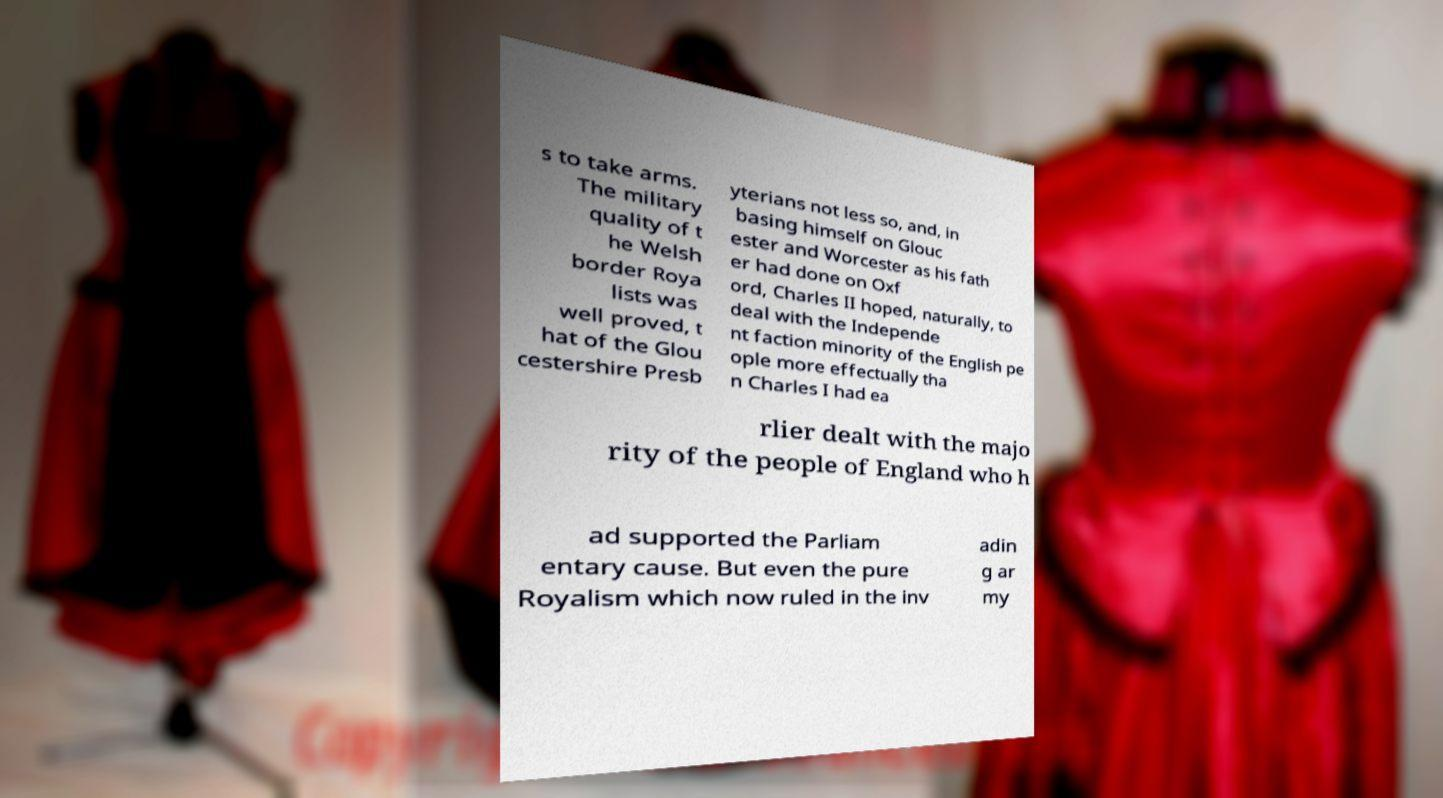Please read and relay the text visible in this image. What does it say? s to take arms. The military quality of t he Welsh border Roya lists was well proved, t hat of the Glou cestershire Presb yterians not less so, and, in basing himself on Glouc ester and Worcester as his fath er had done on Oxf ord, Charles II hoped, naturally, to deal with the Independe nt faction minority of the English pe ople more effectually tha n Charles I had ea rlier dealt with the majo rity of the people of England who h ad supported the Parliam entary cause. But even the pure Royalism which now ruled in the inv adin g ar my 